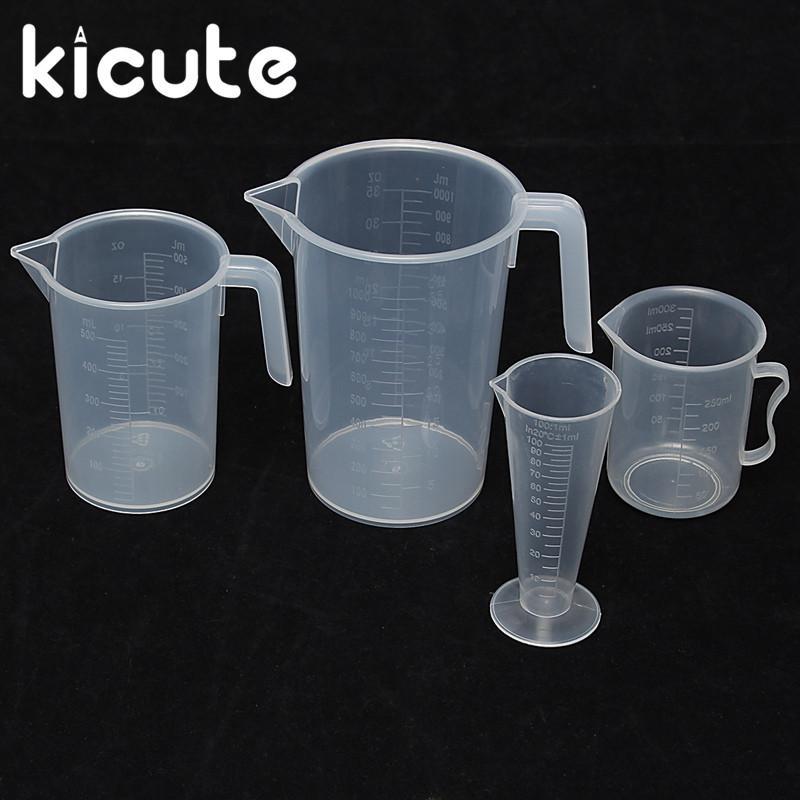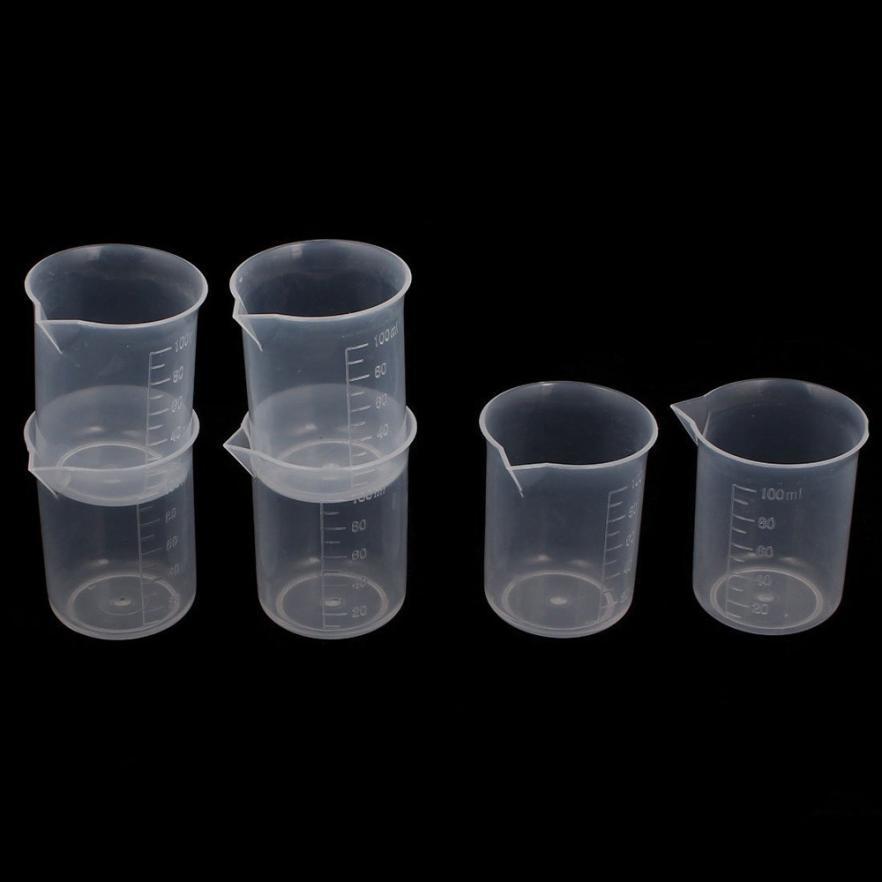The first image is the image on the left, the second image is the image on the right. Considering the images on both sides, is "One image contains exactly 2 measuring cups." valid? Answer yes or no. No. 